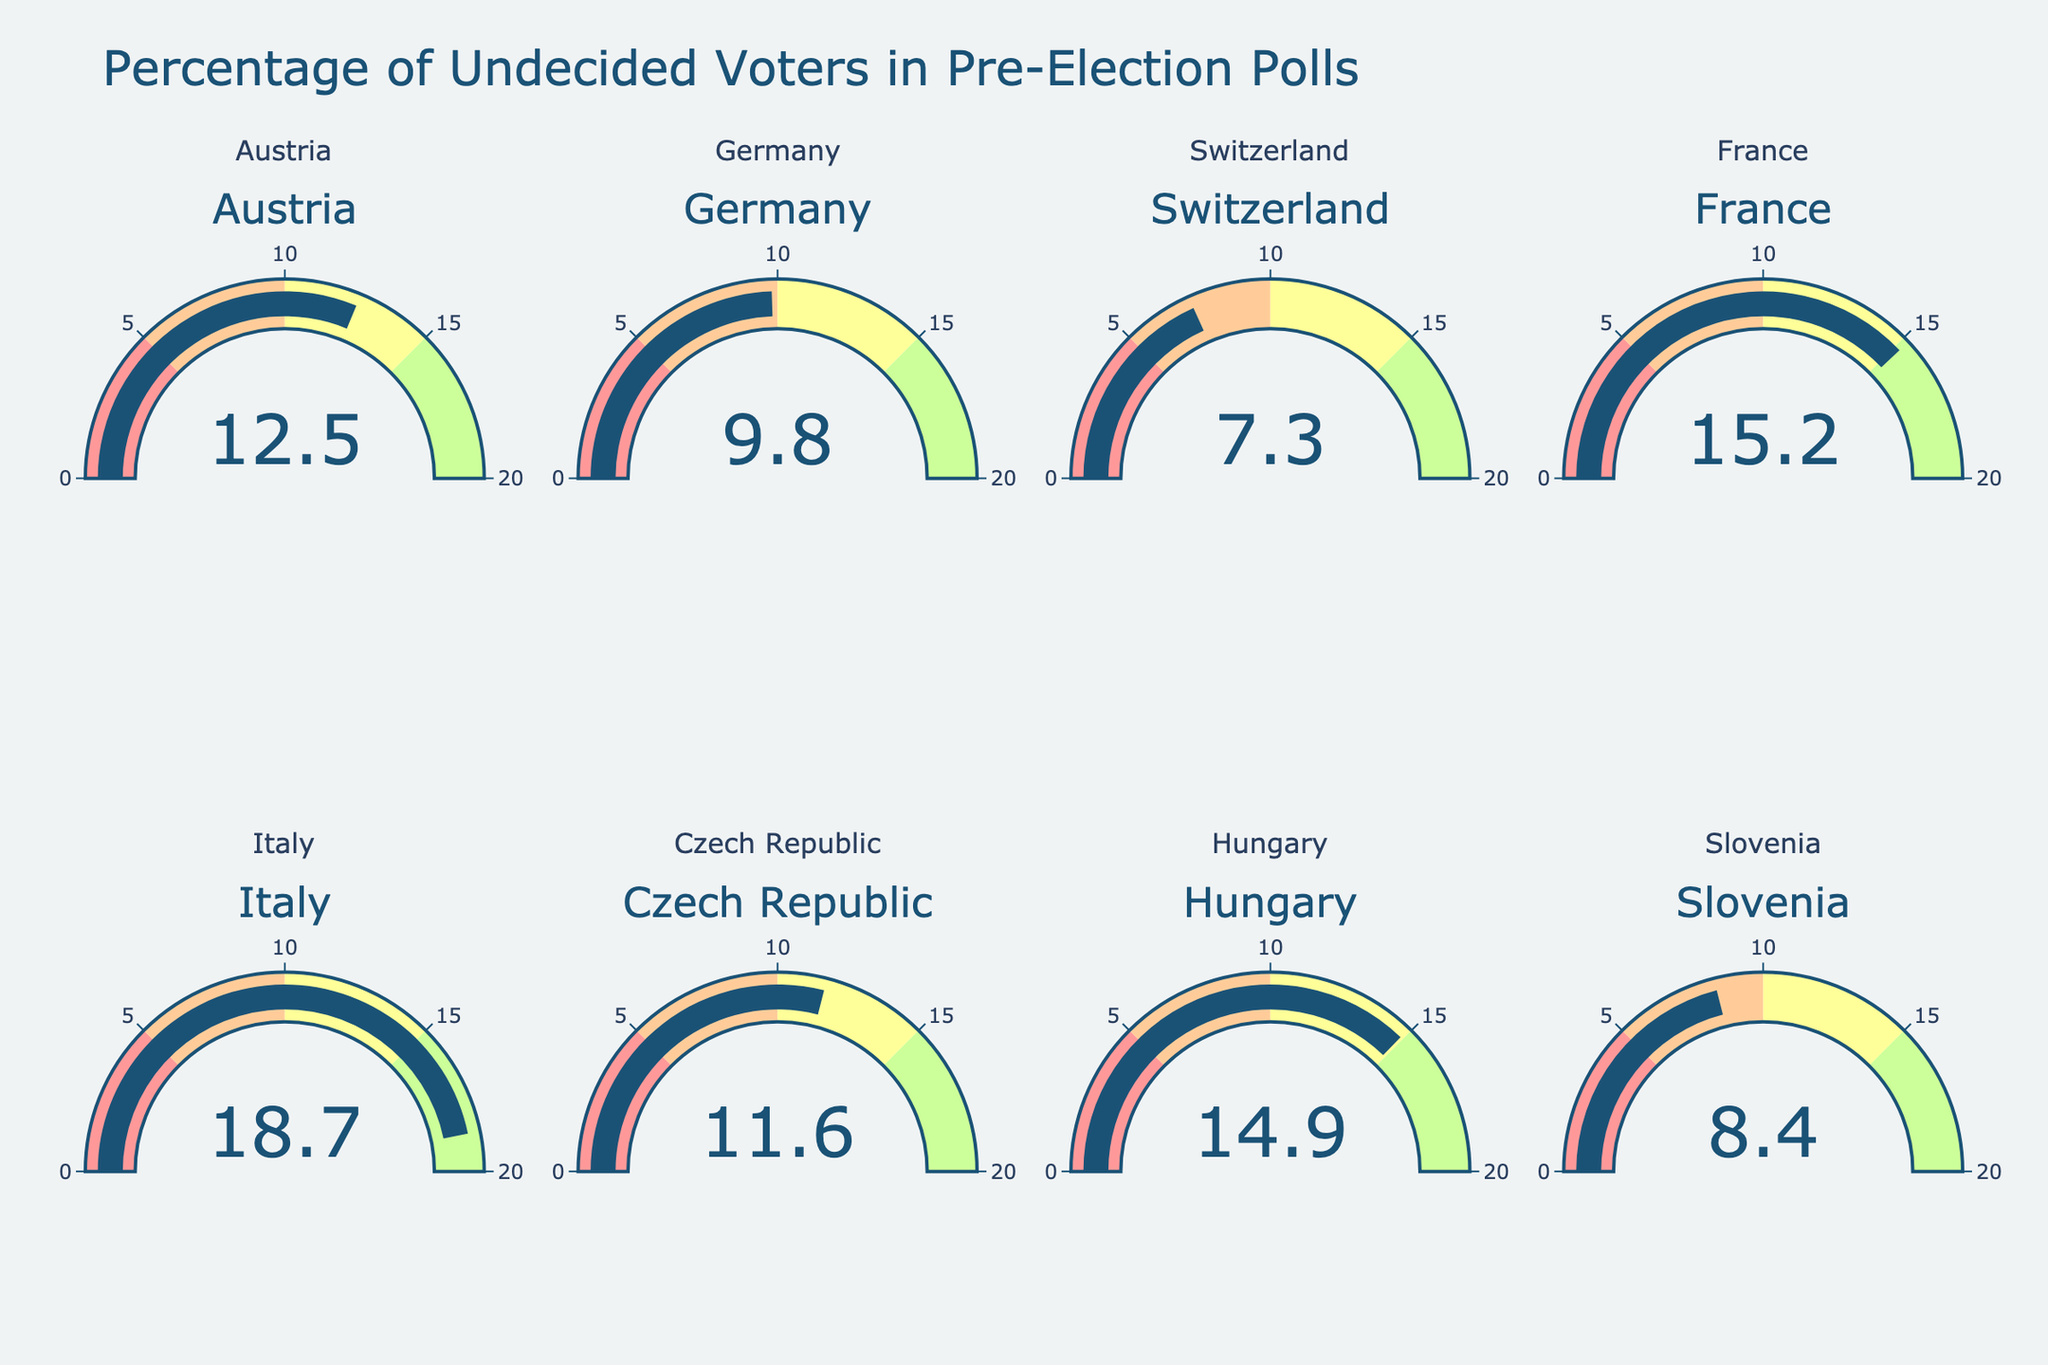What's the title of the chart? The title is typically located at the top of the figure. Look for a large, central text indicating the main theme of the chart.
Answer: Percentage of Undecided Voters in Pre-Election Polls What is the highest percentage of undecided voters? To find this, compare the values displayed on each gauge. Identify the highest value.
Answer: 18.7 Which country has the lowest percentage of undecided voters? Identify and compare the values presented on each gauge. The lowest value marks the country.
Answer: Switzerland What's the average percentage of undecided voters? Calculate the average by adding all the percentages and dividing by the number of countries: (12.5 + 9.8 + 7.3 + 15.2 + 18.7 + 11.6 + 14.9 + 8.4) / 8.
Answer: 12.3 How many countries have a percentage of undecided voters above 10%? Compare each country's percentage. Count the instances where the percentage exceeds 10%.
Answer: 5 What is the difference between the highest and the lowest percentages of undecided voters? Subtract the lowest percentage from the highest: 18.7 - 7.3.
Answer: 11.4 Which countries have undecided voters percentages between 10% and 15%? Identify countries where the values fall within this range by checking each gauge.
Answer: Austria, Czech Republic, Hungary Among Austria, Germany, and France, which country has the highest percentage of undecided voters? Compare the values for Austria (12.5), Germany (9.8), and France (15.2). The highest value indicates the answer.
Answer: France Which countries have undecided voter percentages below 10%? Check the gauges for percentages and list those below 10%.
Answer: Germany, Switzerland, Slovenia How many countries are represented in the figure? Count the subplots or gauges, each representing a country.
Answer: 8 